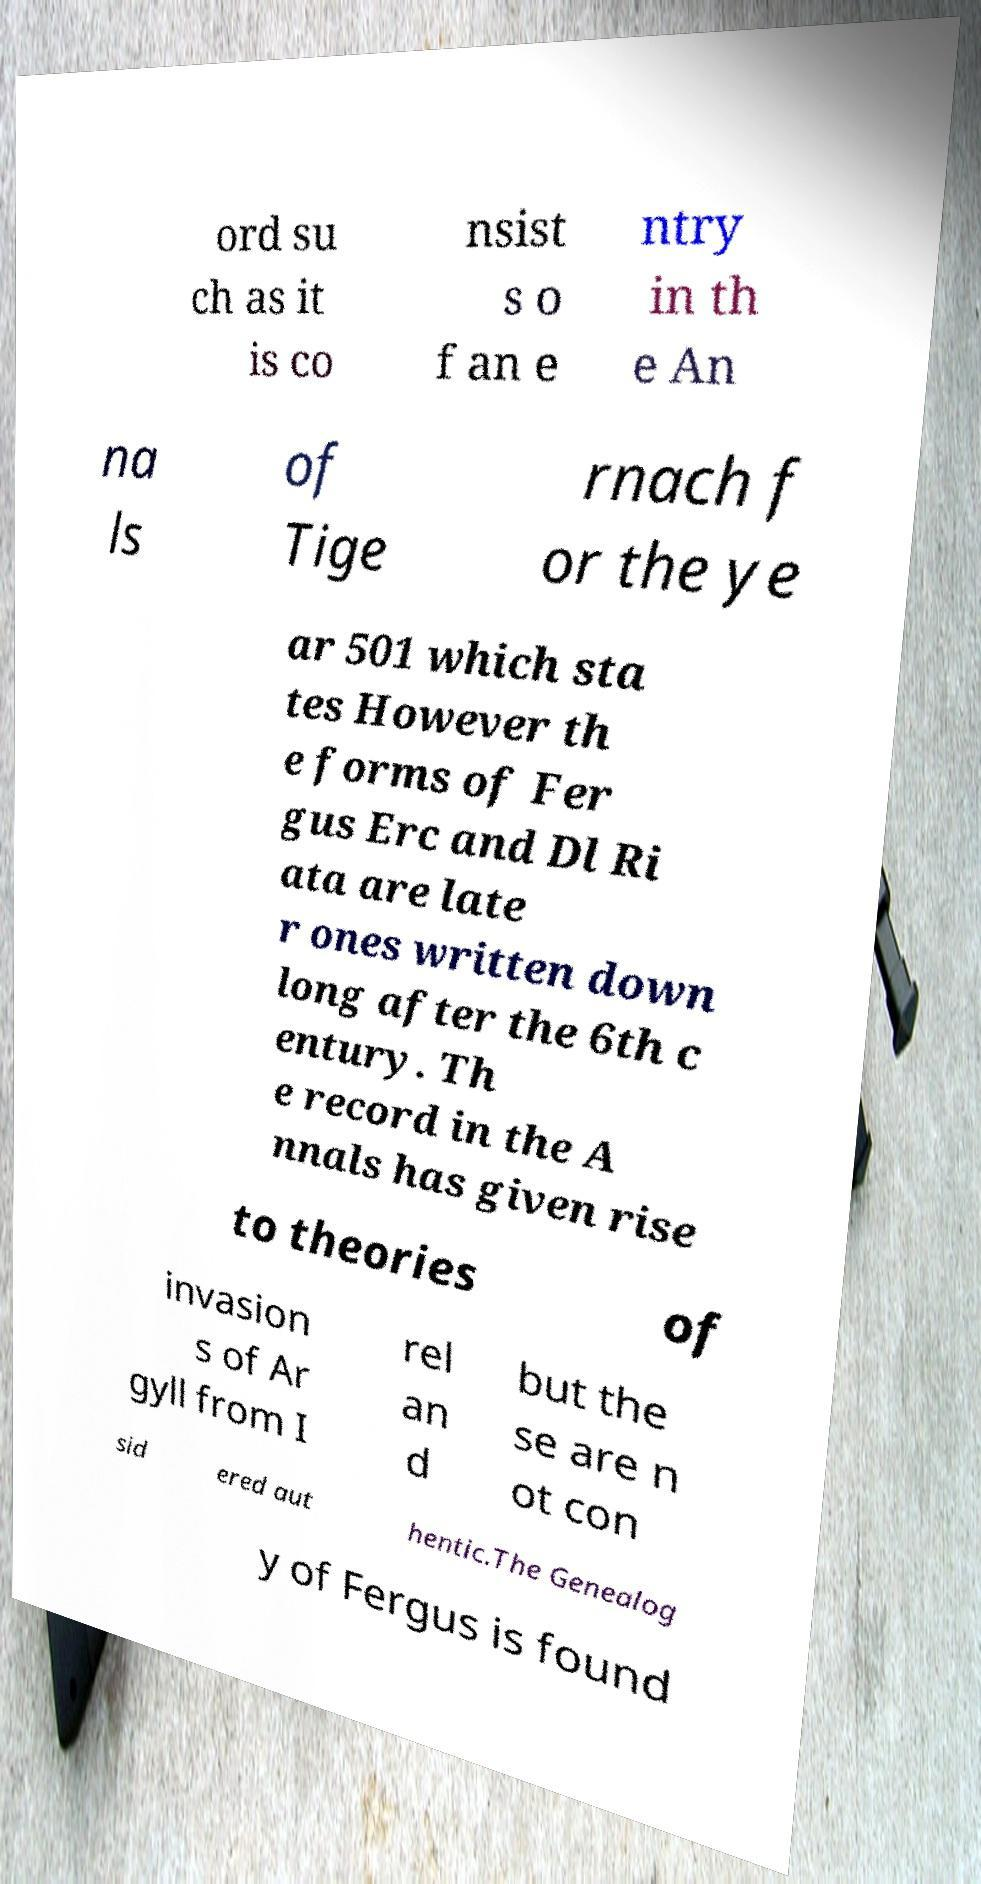Could you assist in decoding the text presented in this image and type it out clearly? ord su ch as it is co nsist s o f an e ntry in th e An na ls of Tige rnach f or the ye ar 501 which sta tes However th e forms of Fer gus Erc and Dl Ri ata are late r ones written down long after the 6th c entury. Th e record in the A nnals has given rise to theories of invasion s of Ar gyll from I rel an d but the se are n ot con sid ered aut hentic.The Genealog y of Fergus is found 